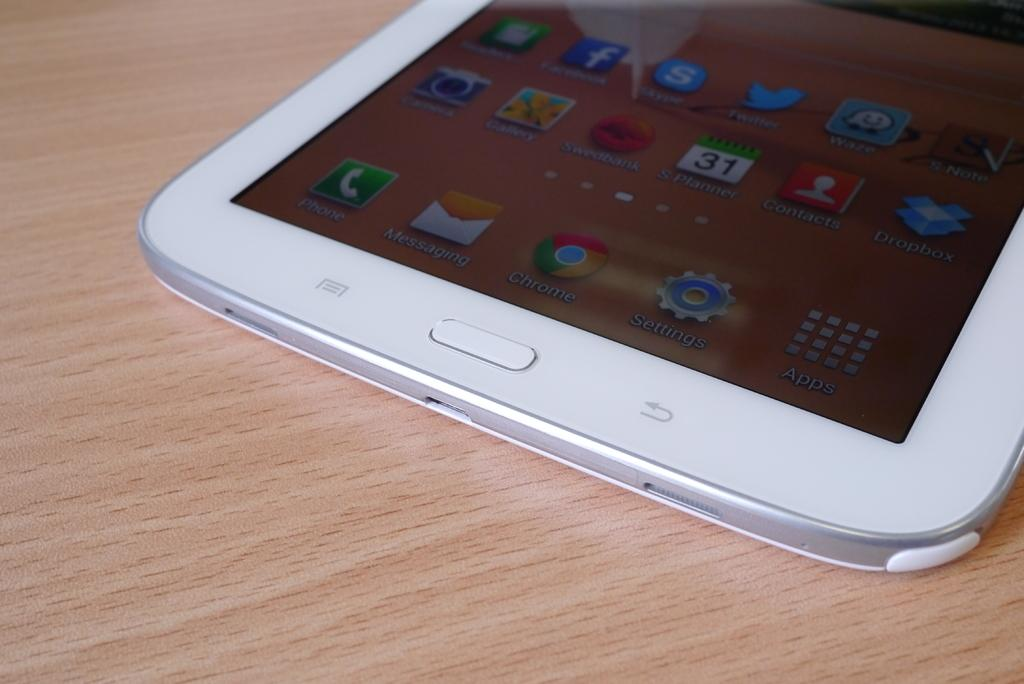What color is the mobile in the image? The mobile is white in color. What is the mobile placed on in the image? The mobile is on a brown color surface. What can be seen on the mobile? There are icons visible on the mobile. What type of skin condition is visible on the pigs in the image? There are no pigs present in the image, so it is not possible to determine if there is any skin condition. 